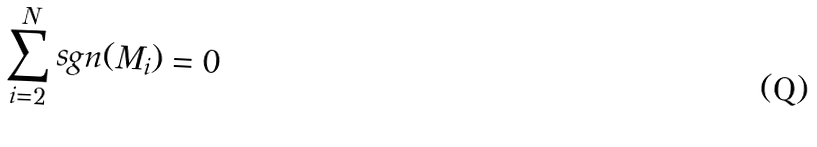Convert formula to latex. <formula><loc_0><loc_0><loc_500><loc_500>\sum _ { i = 2 } ^ { N } s g n ( M _ { i } ) = 0</formula> 